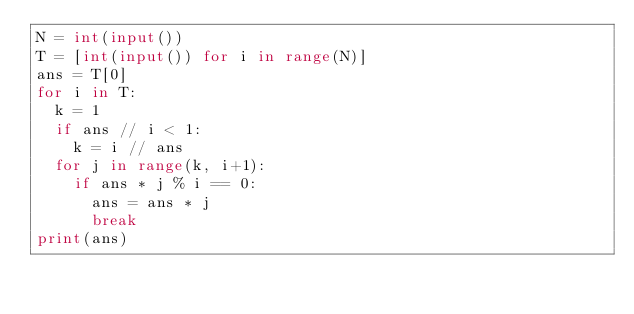Convert code to text. <code><loc_0><loc_0><loc_500><loc_500><_Python_>N = int(input())
T = [int(input()) for i in range(N)]
ans = T[0]
for i in T:
  k = 1
  if ans // i < 1:
    k = i // ans
  for j in range(k, i+1):
    if ans * j % i == 0:
      ans = ans * j
      break
print(ans)</code> 